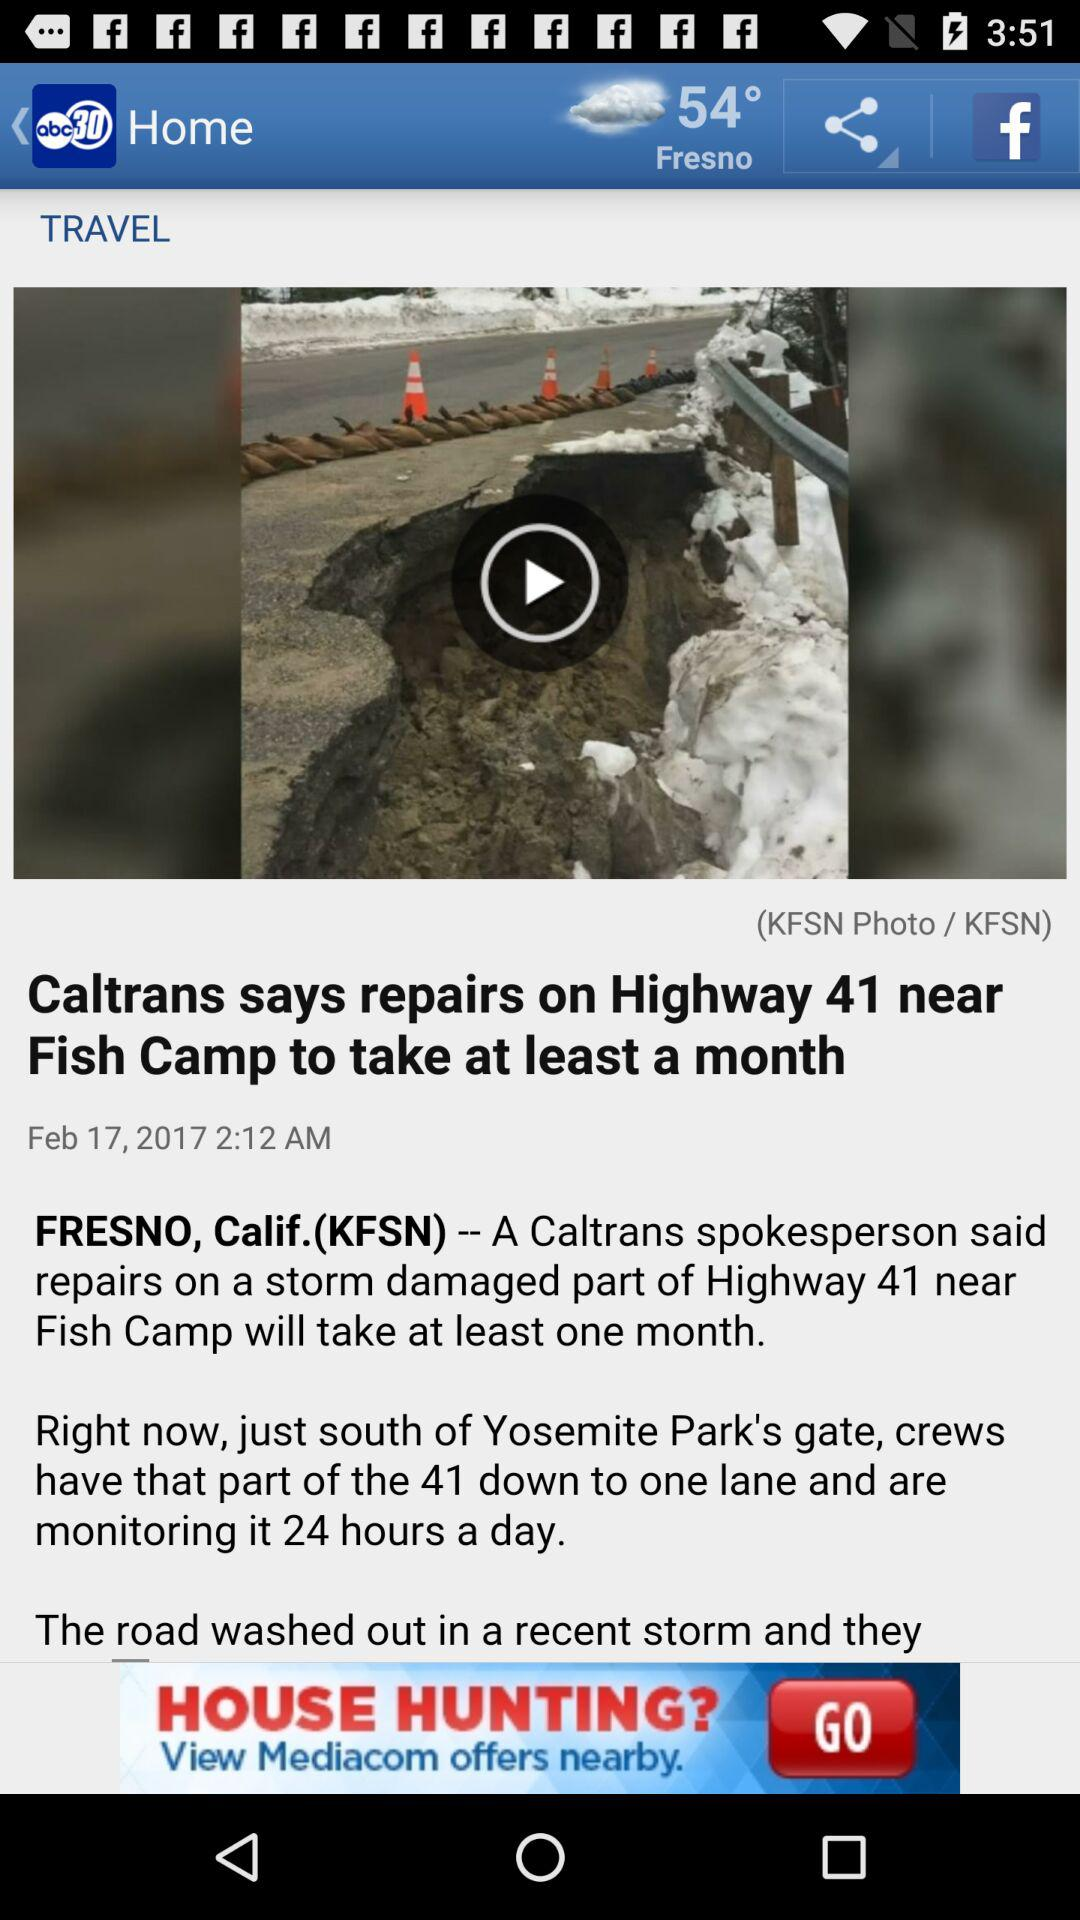What is the time? The time is 2:12 a.m. 